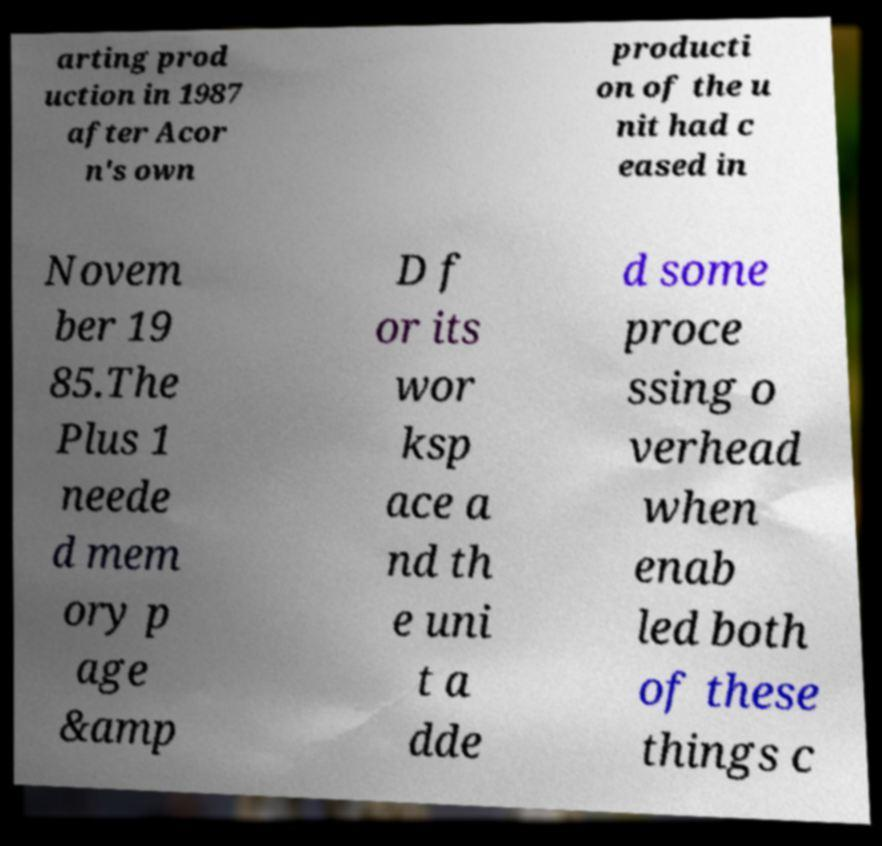For documentation purposes, I need the text within this image transcribed. Could you provide that? arting prod uction in 1987 after Acor n's own producti on of the u nit had c eased in Novem ber 19 85.The Plus 1 neede d mem ory p age &amp D f or its wor ksp ace a nd th e uni t a dde d some proce ssing o verhead when enab led both of these things c 